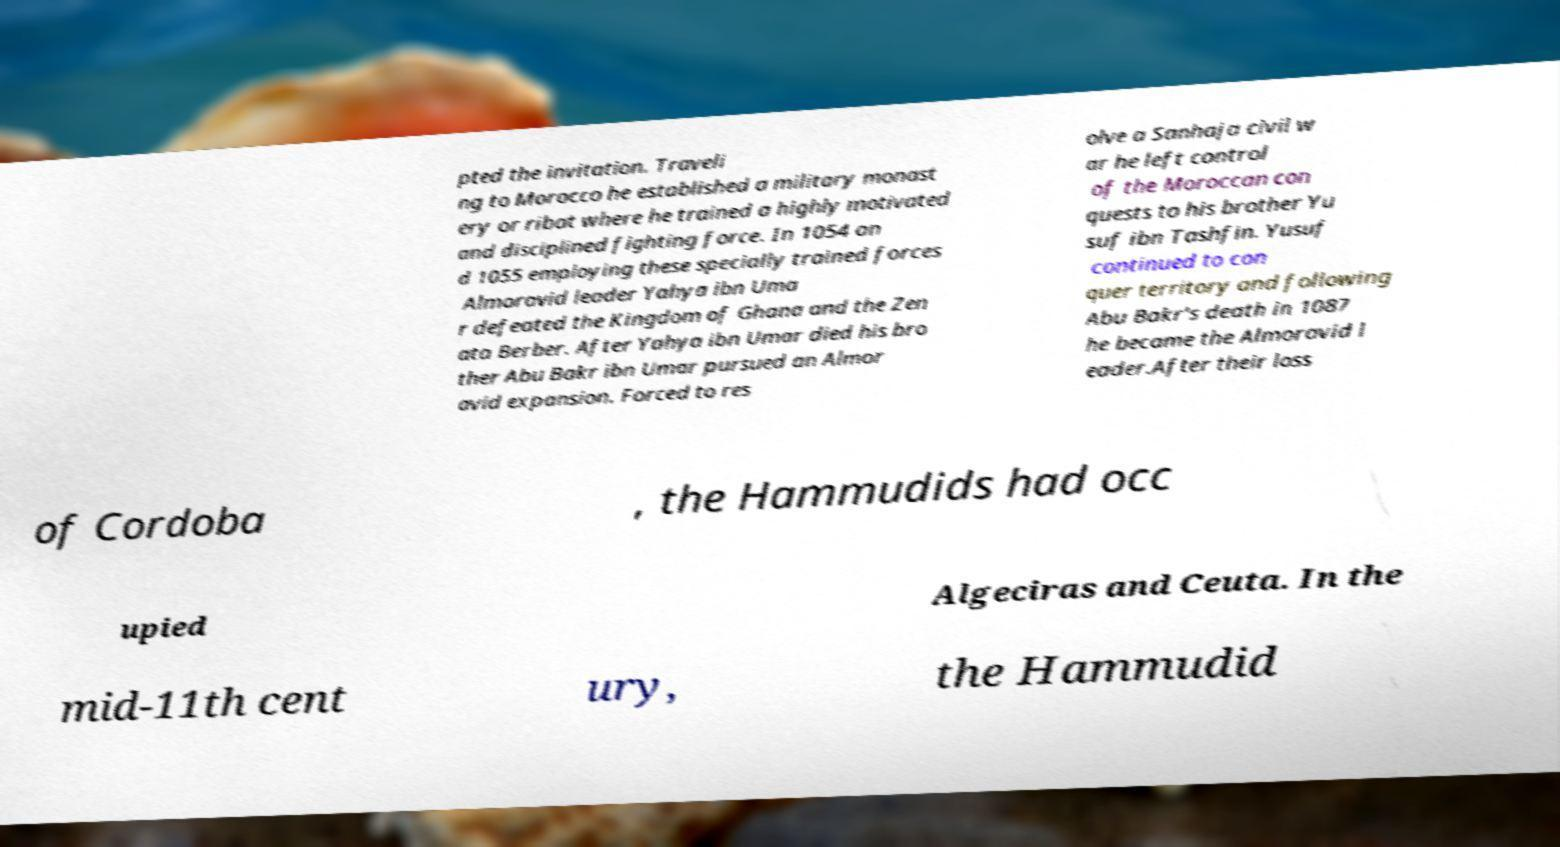For documentation purposes, I need the text within this image transcribed. Could you provide that? pted the invitation. Traveli ng to Morocco he established a military monast ery or ribat where he trained a highly motivated and disciplined fighting force. In 1054 an d 1055 employing these specially trained forces Almoravid leader Yahya ibn Uma r defeated the Kingdom of Ghana and the Zen ata Berber. After Yahya ibn Umar died his bro ther Abu Bakr ibn Umar pursued an Almor avid expansion. Forced to res olve a Sanhaja civil w ar he left control of the Moroccan con quests to his brother Yu suf ibn Tashfin. Yusuf continued to con quer territory and following Abu Bakr's death in 1087 he became the Almoravid l eader.After their loss of Cordoba , the Hammudids had occ upied Algeciras and Ceuta. In the mid-11th cent ury, the Hammudid 